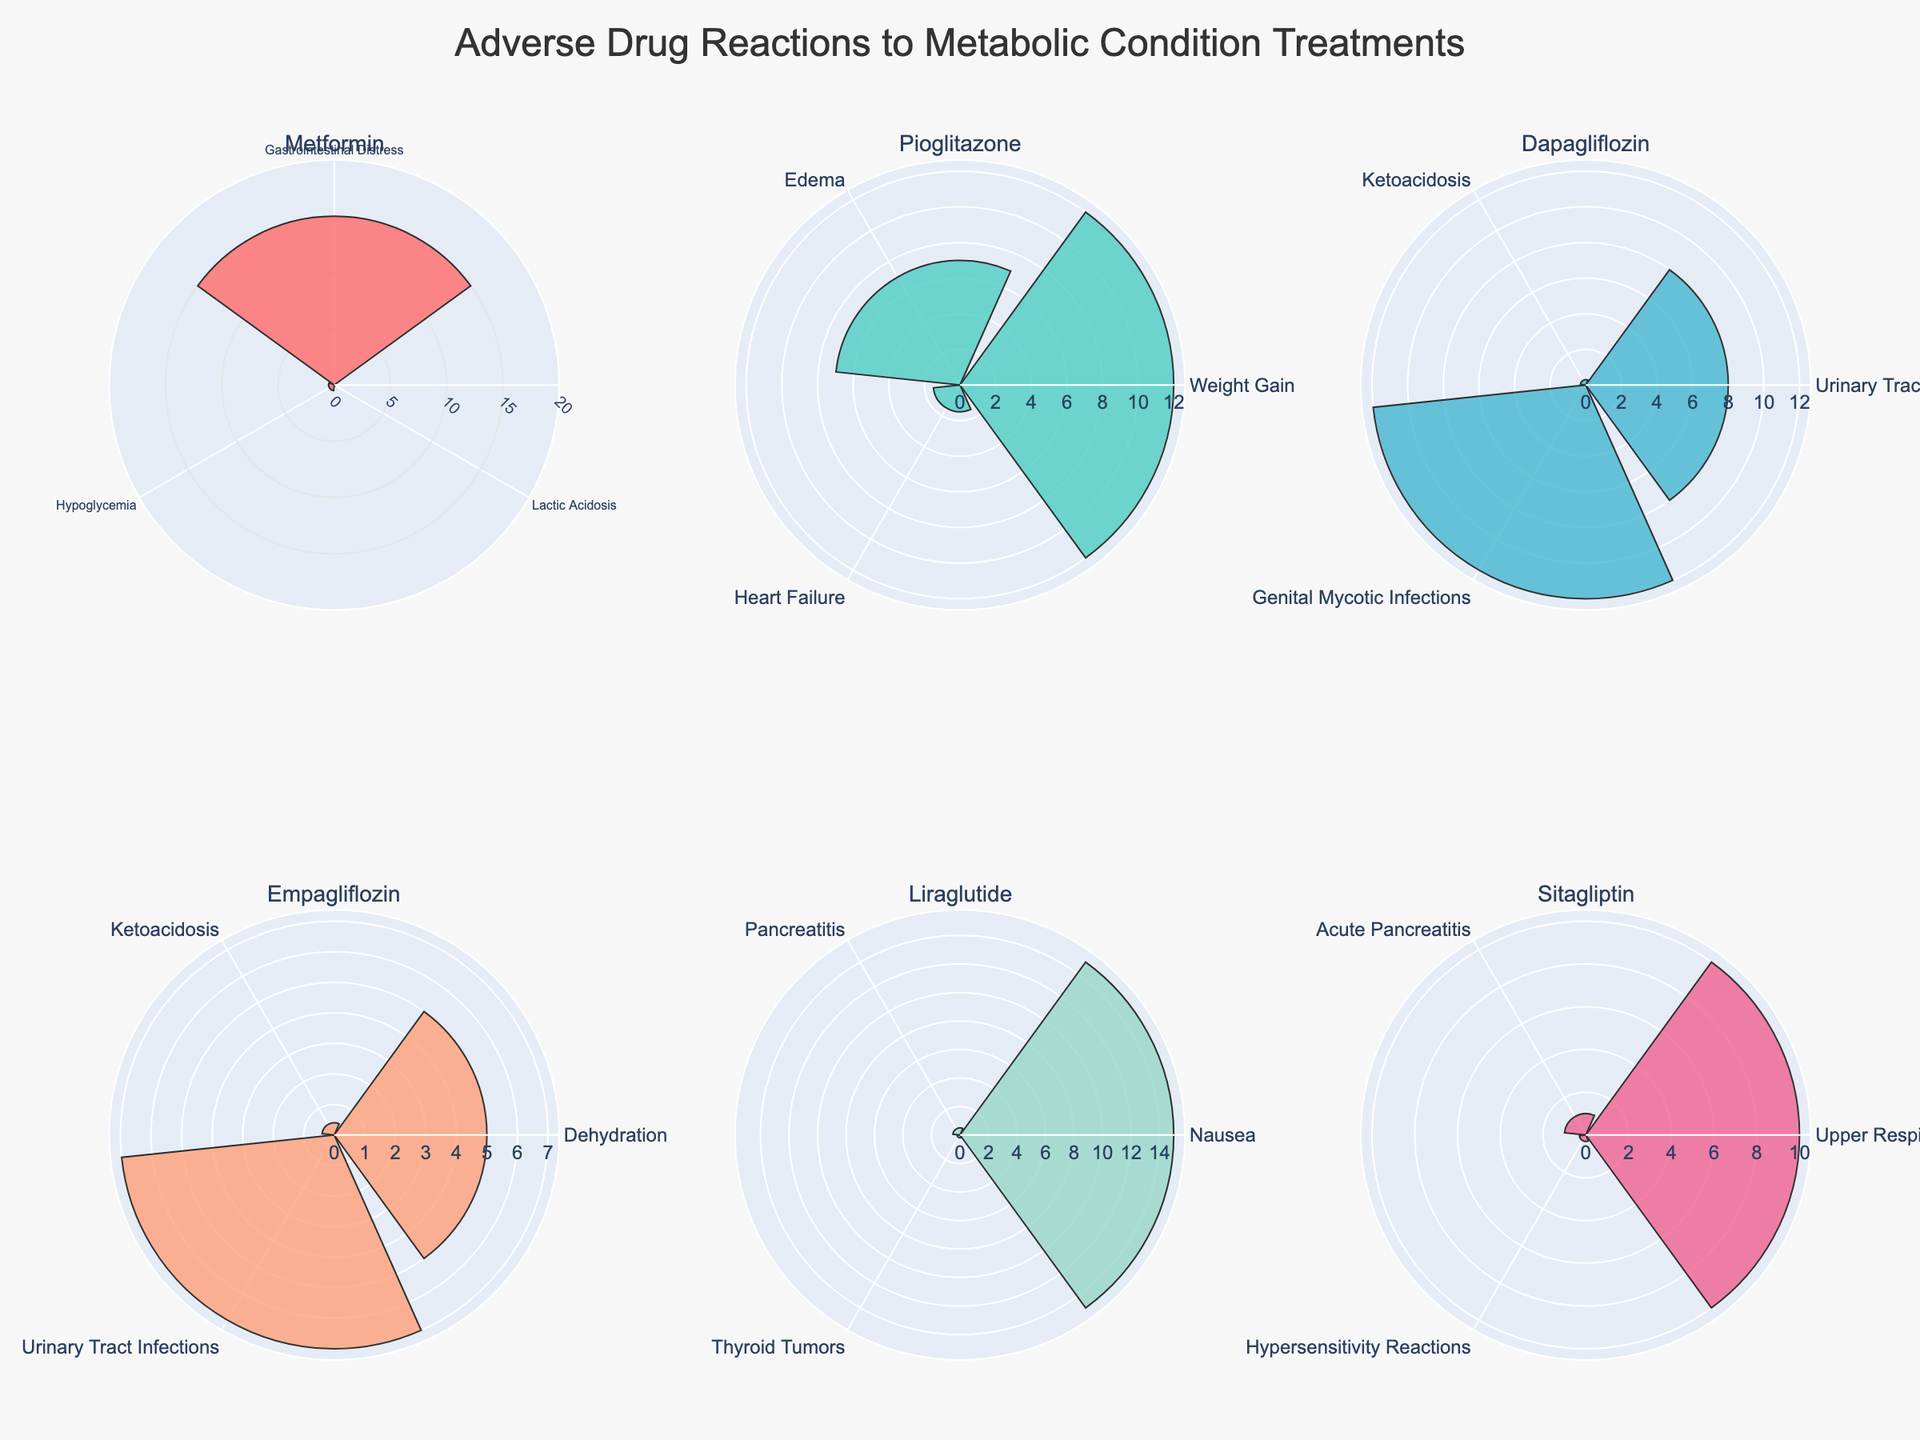What is the title of the figure? The title is located at the top of the figure, clearly stating its purpose. It is written in a larger font size and centered.
Answer: Adverse Drug Reactions to Metabolic Condition Treatments Which drug shows the highest frequency of gastrointestinal distress? Look at each subplot and identify the one showing the largest bar representing gastrointestinal distress.
Answer: Metformin How many adverse reaction types are displayed for Liraglutide? Count the number of bars in the subplot titled "Liraglutide". Each bar represents a different adverse reaction type.
Answer: 3 Which drug has the highest frequency of weight gain as an adverse reaction? Look at the subplots and find the one with the tallest bar labeled "Weight Gain".
Answer: Pioglitazone Between Dapagliflozin and Empagliflozin, which drug has a higher frequency of urinary tract infections? Compare the heights of the bars labeled "Urinary Tract Infections" in the subplots for Dapagliflozin and Empagliflozin.
Answer: Dapagliflozin Which adverse reaction type has the lowest frequency for Sitagliptin and what is its frequency? Identify the shortest bar in the subplot titled "Sitagliptin", and read its label and frequency.
Answer: Hypersensitivity Reactions, 0.3% What is the total number of adverse reactions monitored for Metformin? Count the number of bars in the subplot titled "Metformin". Each bar represents an adverse reaction being monitored.
Answer: 3 For the drug Pioglitazone, what is the combined frequency percentage of weight gain and edema? Find the bars representing weight gain and edema for Pioglitazone and add their frequencies together.
Answer: 19% Which drug has the adverse reaction with the smallest frequency and what is that reaction? Look for the smallest bar across all subplots and read the drug name and the label of this bar.
Answer: Metformin, Lactic Acidosis Are there any drugs that share the same adverse reactions? Compare the labels of bars across different subplots and identify any common adverse reactions.
Answer: Yes (e.g., Pioglitazone and Dapagliflozin both show Edema, Dapagliflozin and Empagliflozin both show Urinary Tract Infections) How many drugs have an adverse reaction with a frequency above 10%? Look at each subplot and count the drugs with at least one bar exceeding 10% frequency.
Answer: 4 